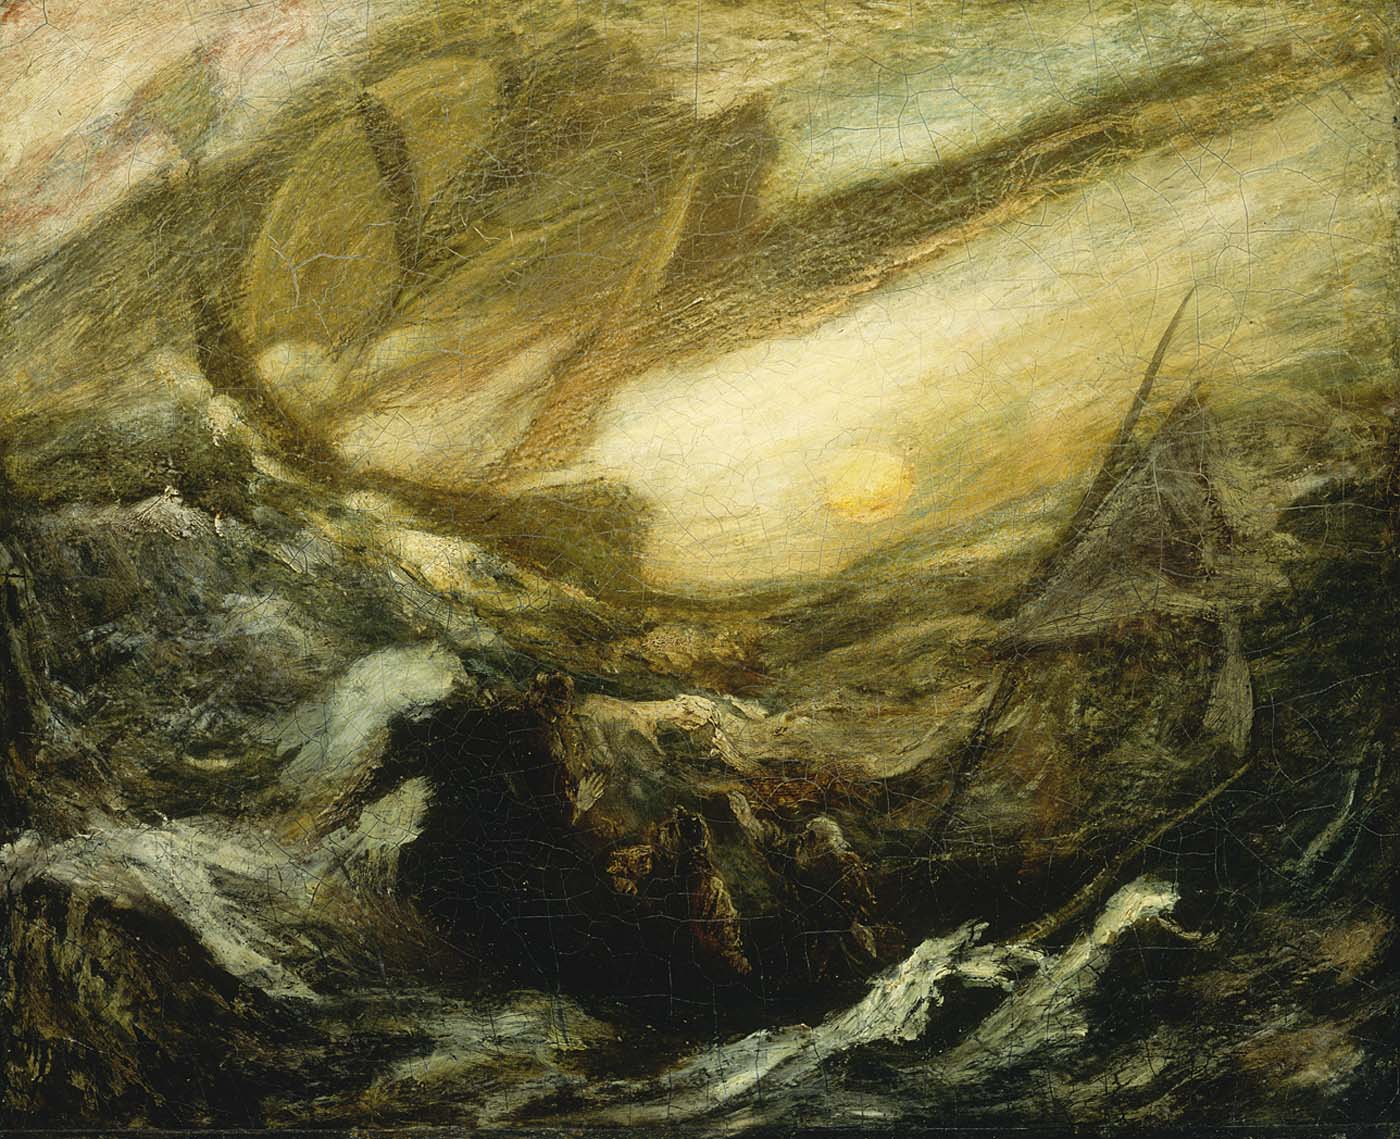What story does this painting narrate? This painting tells the thrilling story of a fierce battle between man and the forces of nature. The chaotic sea, with its towering waves, suggests a perilous journey taken by sailors who must confront the wrath of the deep ocean. The glowing sun in the background serves as a beacon of hope and survival amidst the turmoil. Imagine a legendary voyage, where mythical sea creatures lurk beneath the surface and storms test the sailors' courage and resilience. The scene may symbolize the eternal struggle and harmony between humanity and the natural world. 